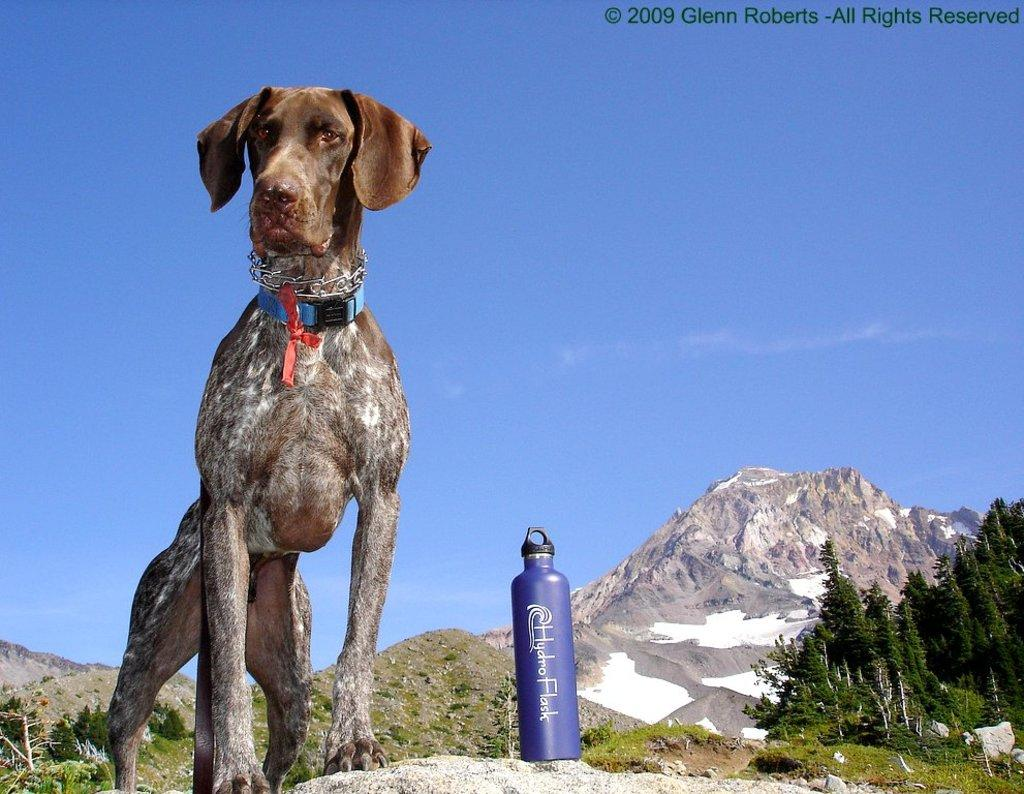What animal can be seen in the image? There is a dog in the image. Where is the dog positioned in the image? The dog is standing on a rock. What object is beside the dog? There is a bottle beside the dog. What type of vegetation is visible in the image? There are trees visible in the image. What geographical feature can be seen in the background of the image? There is a mountain in the background of the image. How does the dog perform magic tricks in the image? The dog does not perform magic tricks in the image; it is simply standing on a rock. 